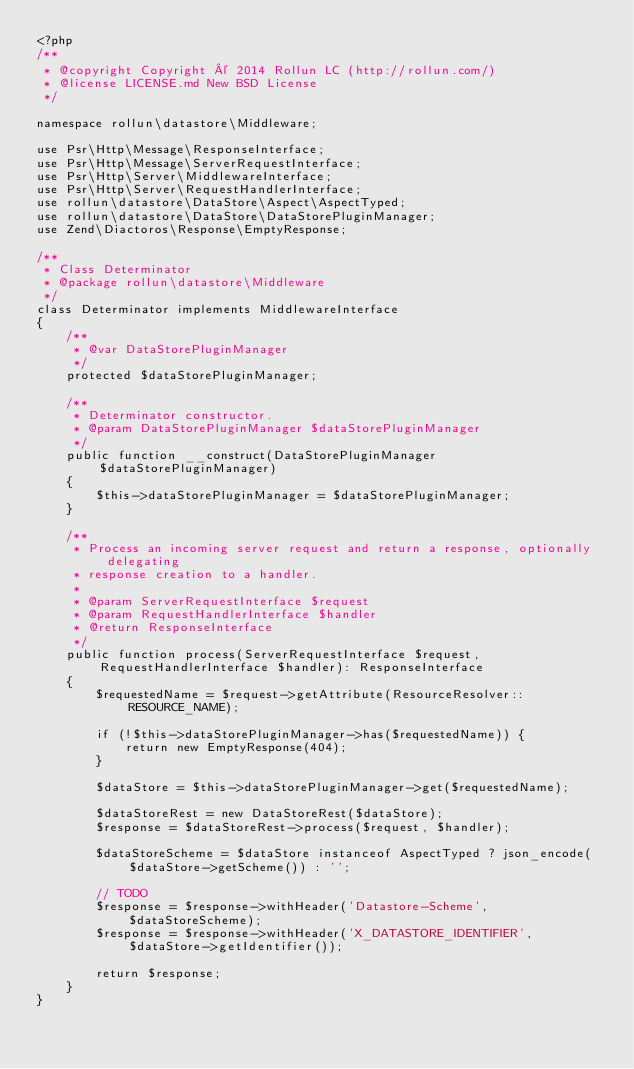<code> <loc_0><loc_0><loc_500><loc_500><_PHP_><?php
/**
 * @copyright Copyright © 2014 Rollun LC (http://rollun.com/)
 * @license LICENSE.md New BSD License
 */

namespace rollun\datastore\Middleware;

use Psr\Http\Message\ResponseInterface;
use Psr\Http\Message\ServerRequestInterface;
use Psr\Http\Server\MiddlewareInterface;
use Psr\Http\Server\RequestHandlerInterface;
use rollun\datastore\DataStore\Aspect\AspectTyped;
use rollun\datastore\DataStore\DataStorePluginManager;
use Zend\Diactoros\Response\EmptyResponse;

/**
 * Class Determinator
 * @package rollun\datastore\Middleware
 */
class Determinator implements MiddlewareInterface
{
    /**
     * @var DataStorePluginManager
     */
    protected $dataStorePluginManager;

    /**
     * Determinator constructor.
     * @param DataStorePluginManager $dataStorePluginManager
     */
    public function __construct(DataStorePluginManager $dataStorePluginManager)
    {
        $this->dataStorePluginManager = $dataStorePluginManager;
    }

    /**
     * Process an incoming server request and return a response, optionally delegating
     * response creation to a handler.
     *
     * @param ServerRequestInterface $request
     * @param RequestHandlerInterface $handler
     * @return ResponseInterface
     */
    public function process(ServerRequestInterface $request, RequestHandlerInterface $handler): ResponseInterface
    {
        $requestedName = $request->getAttribute(ResourceResolver::RESOURCE_NAME);

        if (!$this->dataStorePluginManager->has($requestedName)) {
            return new EmptyResponse(404);
        }

        $dataStore = $this->dataStorePluginManager->get($requestedName);

        $dataStoreRest = new DataStoreRest($dataStore);
        $response = $dataStoreRest->process($request, $handler);

        $dataStoreScheme = $dataStore instanceof AspectTyped ? json_encode($dataStore->getScheme()) : '';

        // TODO
        $response = $response->withHeader('Datastore-Scheme', $dataStoreScheme);
        $response = $response->withHeader('X_DATASTORE_IDENTIFIER', $dataStore->getIdentifier());

        return $response;
    }
}
</code> 